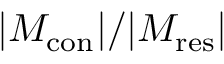Convert formula to latex. <formula><loc_0><loc_0><loc_500><loc_500>| M _ { c o n } | / | M _ { r e s } |</formula> 